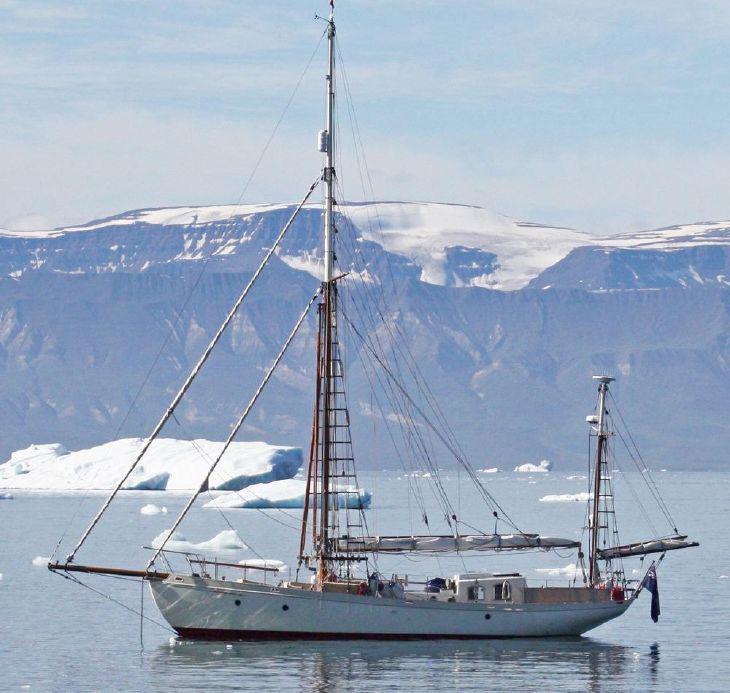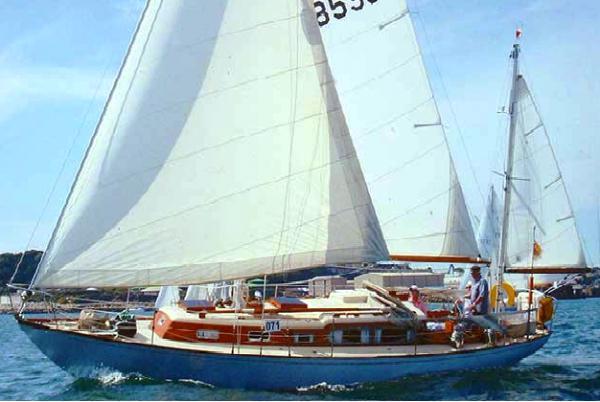The first image is the image on the left, the second image is the image on the right. For the images shown, is this caption "All boat sails are furled." true? Answer yes or no. No. 